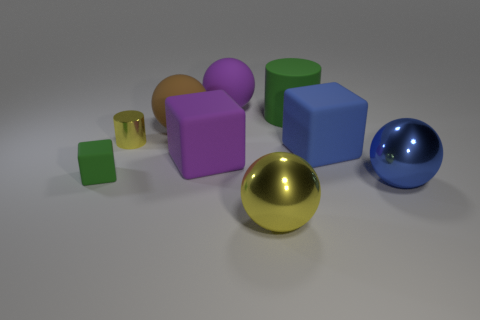There is another matte object that is the same shape as the tiny yellow object; what size is it?
Give a very brief answer. Large. The yellow ball that is the same material as the small yellow thing is what size?
Your response must be concise. Large. There is a tiny cylinder; is it the same color as the large metallic sphere left of the large blue rubber object?
Offer a very short reply. Yes. What is the material of the large object that is behind the yellow cylinder and to the right of the big yellow metallic ball?
Offer a terse response. Rubber. There is another metal object that is the same color as the small shiny thing; what size is it?
Your response must be concise. Large. Do the green matte thing in front of the blue matte object and the big purple object in front of the purple sphere have the same shape?
Give a very brief answer. Yes. Are there any red matte things?
Offer a very short reply. No. There is another big metal thing that is the same shape as the large yellow thing; what color is it?
Your response must be concise. Blue. There is a matte cylinder that is the same size as the blue rubber block; what color is it?
Make the answer very short. Green. Do the big yellow ball and the blue ball have the same material?
Ensure brevity in your answer.  Yes. 